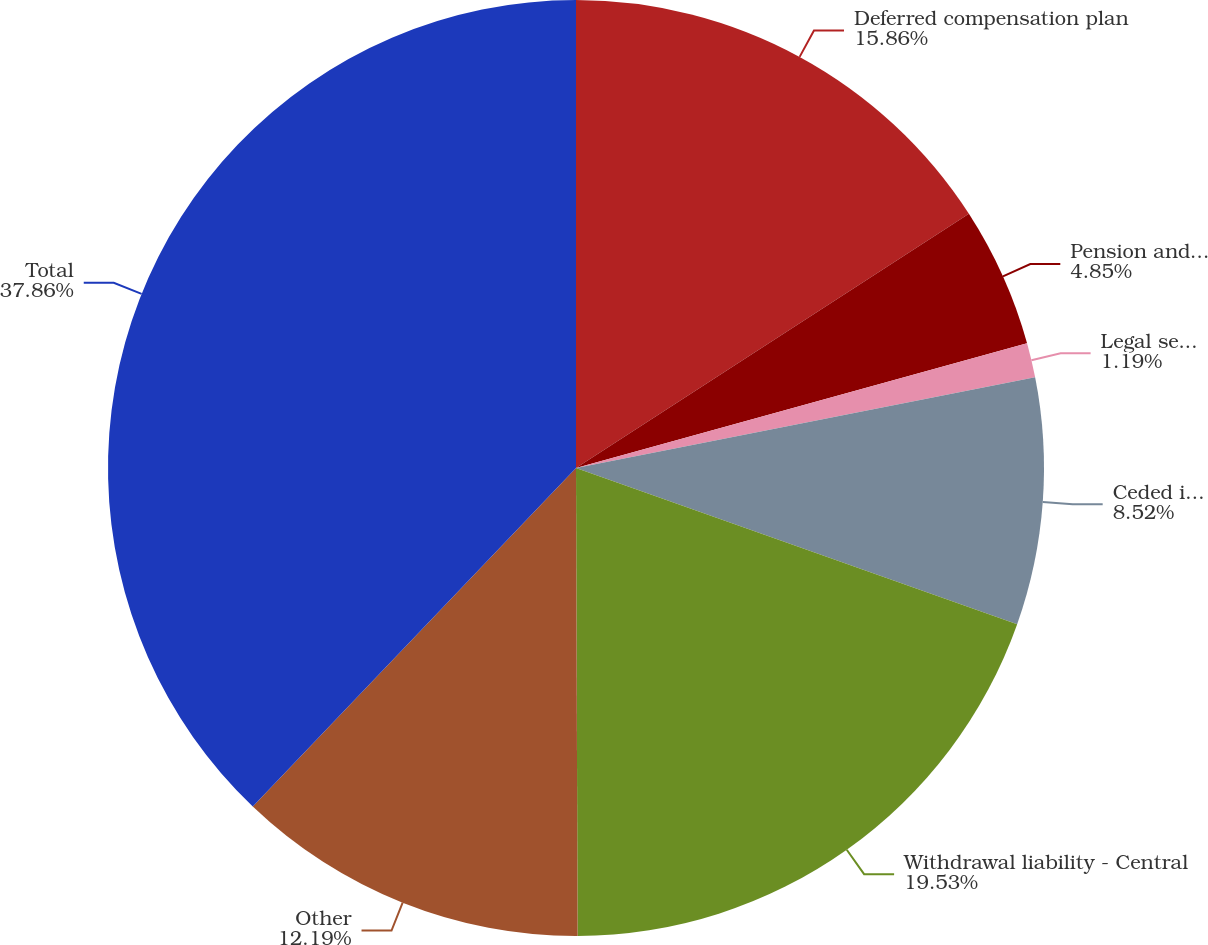<chart> <loc_0><loc_0><loc_500><loc_500><pie_chart><fcel>Deferred compensation plan<fcel>Pension and other<fcel>Legal settlement reserves<fcel>Ceded insurance reserves<fcel>Withdrawal liability - Central<fcel>Other<fcel>Total<nl><fcel>15.86%<fcel>4.85%<fcel>1.19%<fcel>8.52%<fcel>19.53%<fcel>12.19%<fcel>37.87%<nl></chart> 